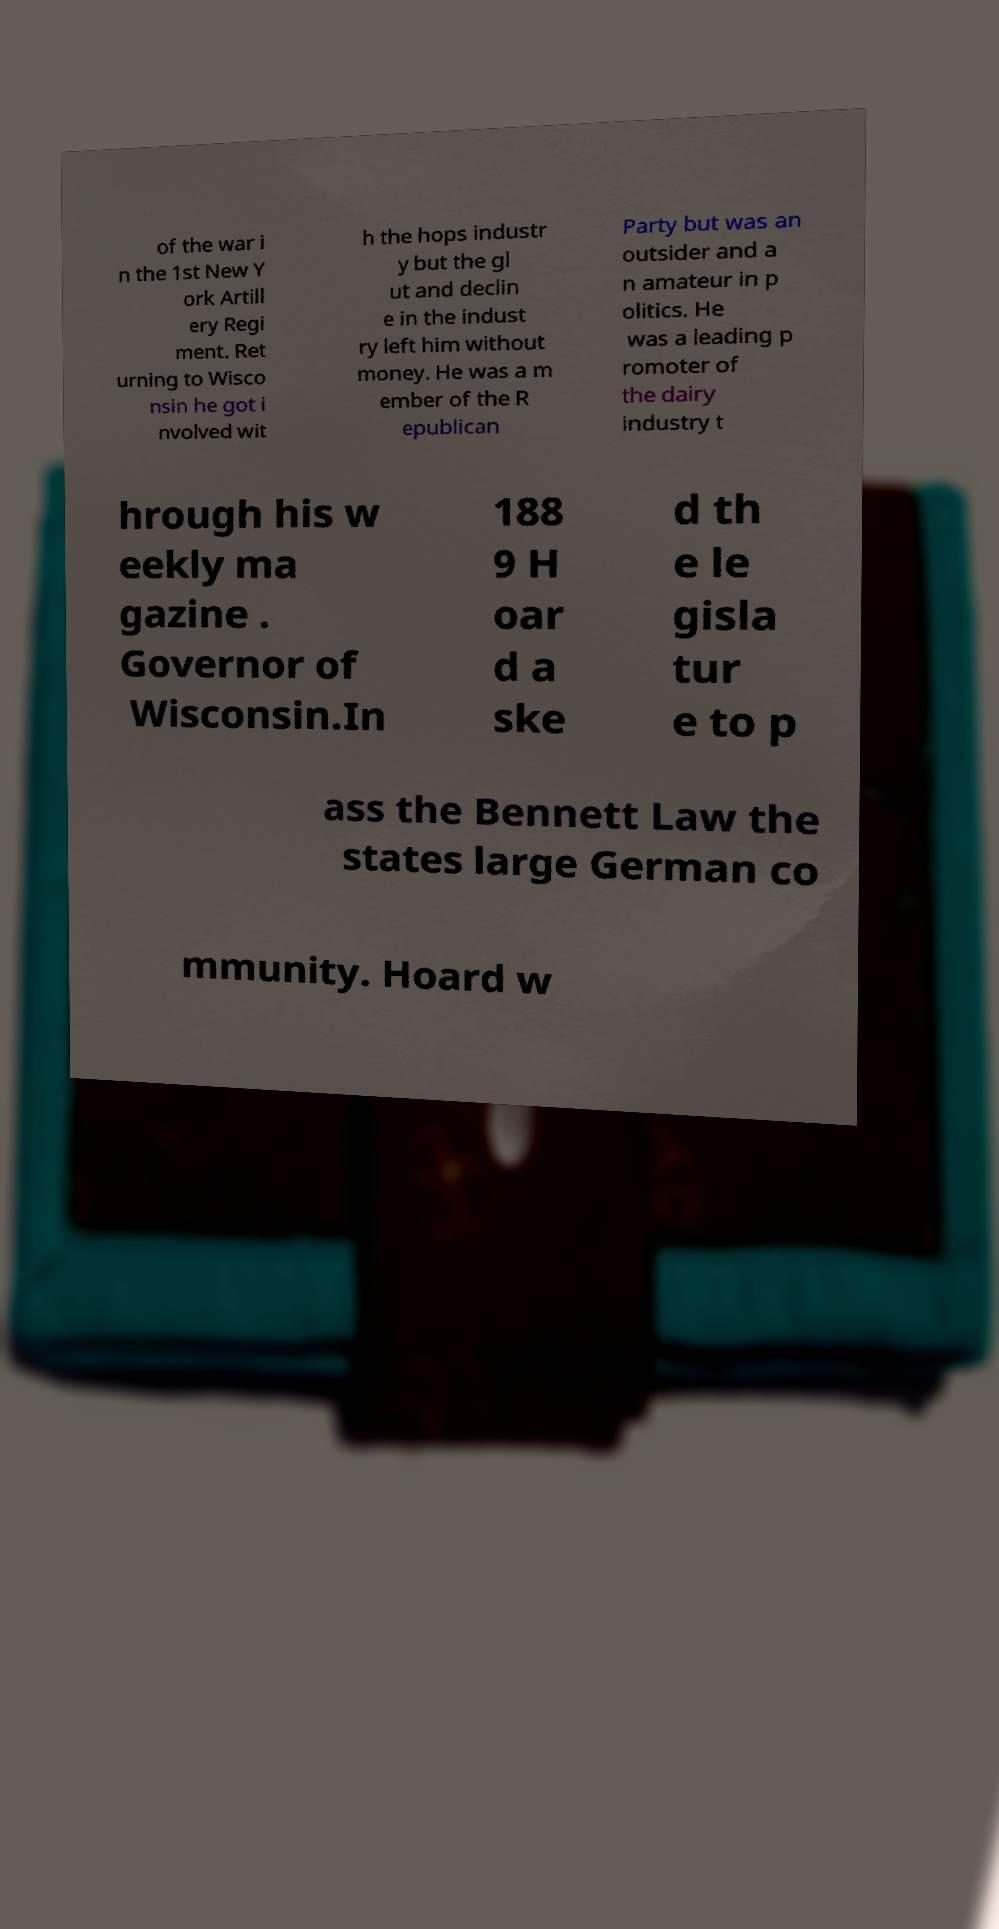Could you assist in decoding the text presented in this image and type it out clearly? of the war i n the 1st New Y ork Artill ery Regi ment. Ret urning to Wisco nsin he got i nvolved wit h the hops industr y but the gl ut and declin e in the indust ry left him without money. He was a m ember of the R epublican Party but was an outsider and a n amateur in p olitics. He was a leading p romoter of the dairy industry t hrough his w eekly ma gazine . Governor of Wisconsin.In 188 9 H oar d a ske d th e le gisla tur e to p ass the Bennett Law the states large German co mmunity. Hoard w 